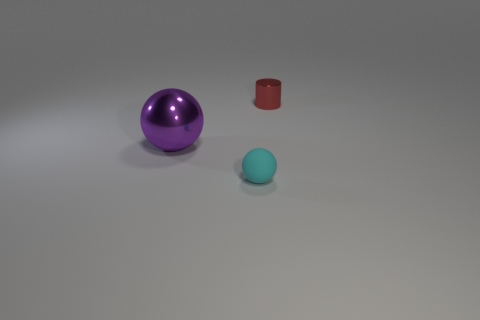Add 2 purple objects. How many objects exist? 5 Subtract all balls. How many objects are left? 1 Add 1 rubber things. How many rubber things are left? 2 Add 2 cyan things. How many cyan things exist? 3 Subtract 0 brown cylinders. How many objects are left? 3 Subtract all green rubber things. Subtract all shiny objects. How many objects are left? 1 